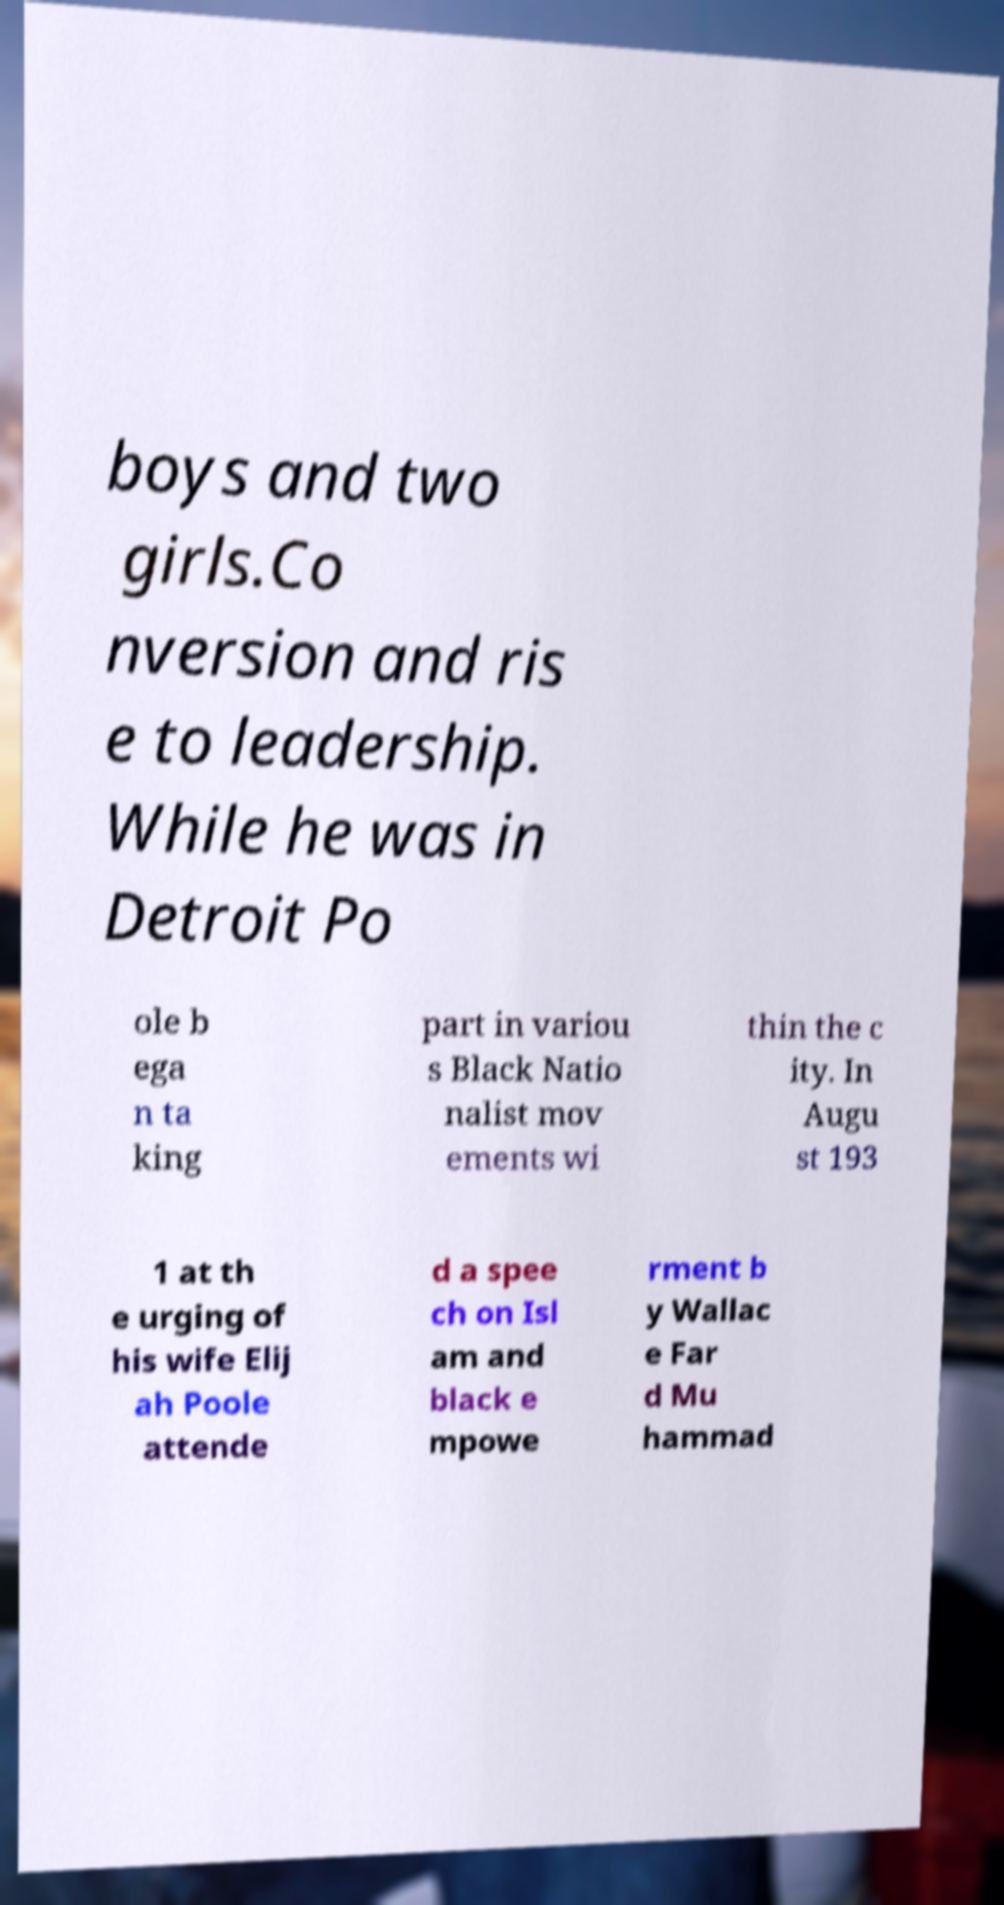Could you assist in decoding the text presented in this image and type it out clearly? boys and two girls.Co nversion and ris e to leadership. While he was in Detroit Po ole b ega n ta king part in variou s Black Natio nalist mov ements wi thin the c ity. In Augu st 193 1 at th e urging of his wife Elij ah Poole attende d a spee ch on Isl am and black e mpowe rment b y Wallac e Far d Mu hammad 